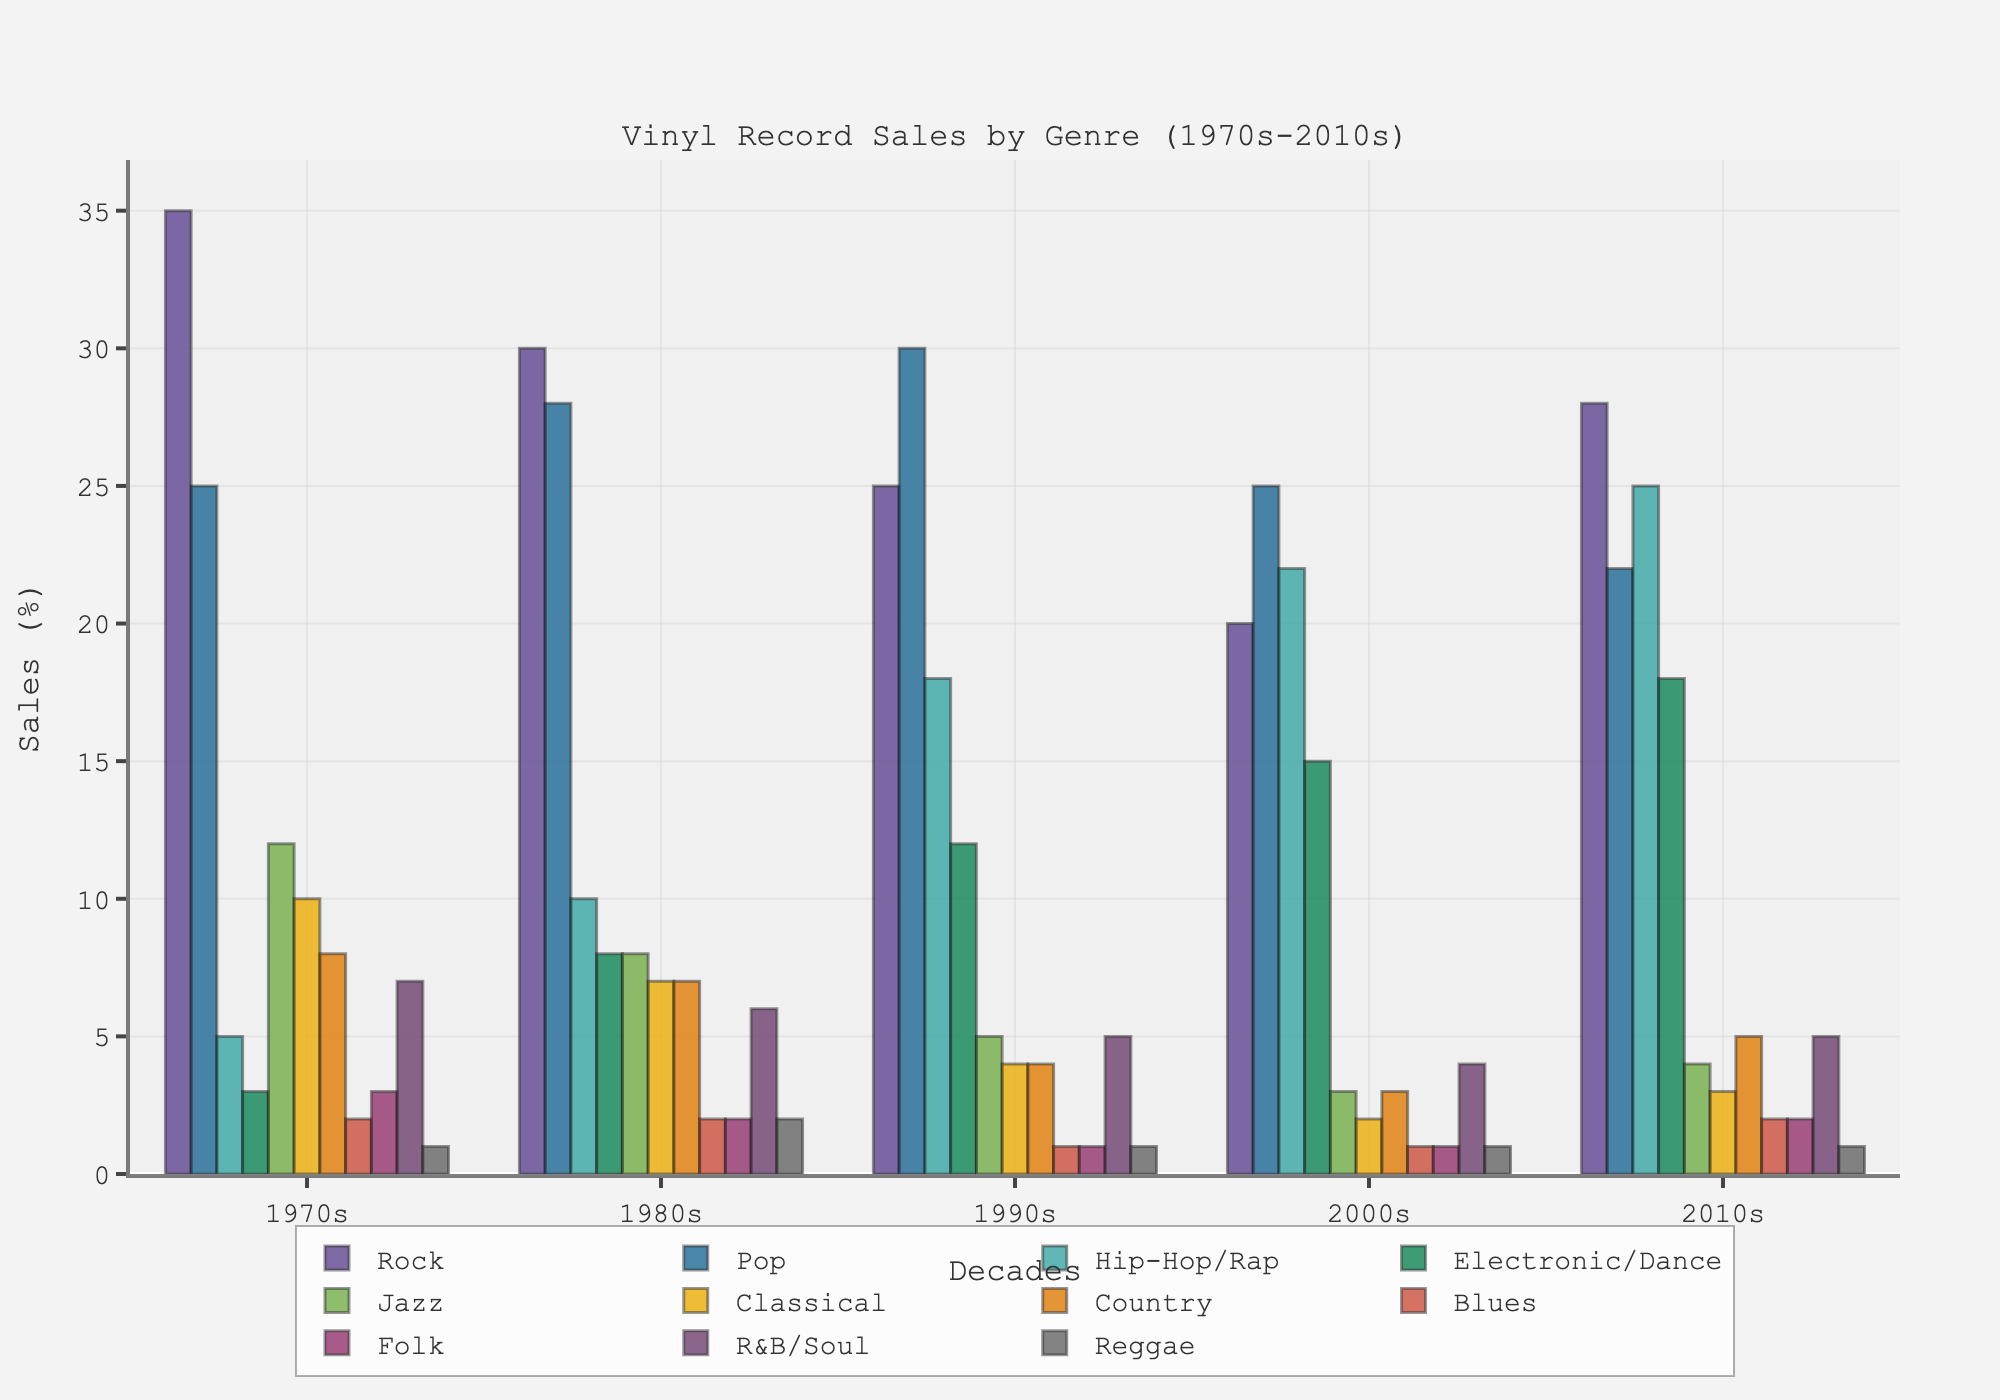Which genre saw the largest increase in vinyl record sales from the 1970s to the 2010s? To determine this, we need to find the difference in sales between the 1970s and 2010s for each genre. The largest difference is seen in Hip-Hop/Rap, which increased by 20 (from 5% to 25%).
Answer: Hip-Hop/Rap Which decade had the highest average vinyl record sales across all genres? First, calculate the average sales for each decade: 1970s (11.72), 1980s (12.09), 1990s (11.82), 2000s (9.82), and 2010s (10.27). The 1980s have the highest average.
Answer: 1980s How do the vinyl sales of Rock in the 1980s compare to the sales of Pop in the same decade? Rock had 30% of the sales, while Pop had 28%. Therefore, Rock had higher sales than Pop in the 1980s.
Answer: Rock Which genre had the biggest decline in vinyl sales from the 1970s to the 2010s? Determine the decline for each genre. Jazz and Classical both declined by 8% (from Jazz: 12% to 4%, Classical: 10% to 2%). So the largest decline is shared by Jazz and Classical.
Answer: Jazz and Classical What percentage of vinyl record sales did R&B/Soul hold in the 1990s? Refer to the 1990s for R&B/Soul, which stands at 5%.
Answer: 5% Which genre consistently had sales equal to or below 2% across all decades? Check each genre: Blues and Folk both had sales at or below 2% in every decade.
Answer: Blues and Folk For which decade did Country see its lowest vinyl sales percentage? Looking at the data, Country's lowest percentage is in the 2000s, where it had 3%.
Answer: 2000s Did Jazz see an increase or decrease in sales from the 2000s to the 2010s? Vinyl sales for Jazz were 3% in the 2000s and increased to 4% in the 2010s.
Answer: Increase Which genres had their peak vinyl sales in the 1990s? Pop and Hip-Hop/Rap had their highest sales in the 1990s, with Pop at 30% and Hip-Hop/Rap at 18%.
Answer: Pop and Hip-Hop/Rap 